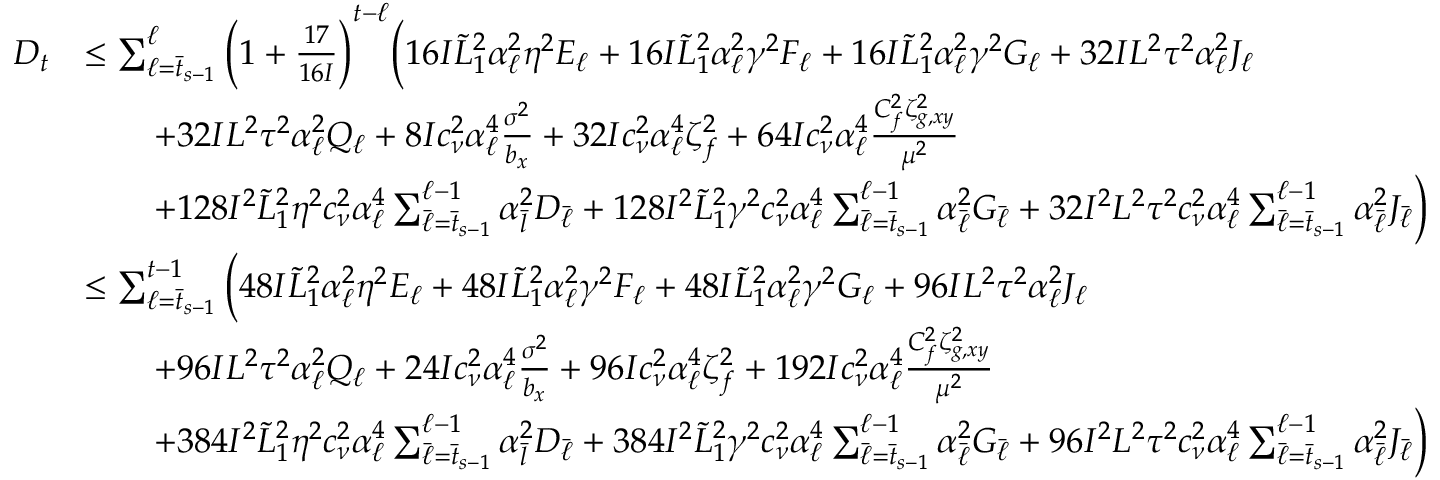<formula> <loc_0><loc_0><loc_500><loc_500>\begin{array} { r l } { D _ { t } } & { \leq \sum _ { \ell = \bar { t } _ { s - 1 } } ^ { \ell } \left ( 1 + \frac { 1 7 } { 1 6 I } \right ) ^ { t - \ell } \left ( 1 6 I \tilde { L } _ { 1 } ^ { 2 } \alpha _ { \ell } ^ { 2 } \eta ^ { 2 } E _ { \ell } + 1 6 I \tilde { L } _ { 1 } ^ { 2 } \alpha _ { \ell } ^ { 2 } \gamma ^ { 2 } F _ { \ell } + 1 6 I \tilde { L } _ { 1 } ^ { 2 } \alpha _ { \ell } ^ { 2 } \gamma ^ { 2 } G _ { \ell } + 3 2 I L ^ { 2 } \tau ^ { 2 } \alpha _ { \ell } ^ { 2 } J _ { \ell } } \\ & { \quad + 3 2 I L ^ { 2 } \tau ^ { 2 } \alpha _ { \ell } ^ { 2 } Q _ { \ell } + 8 I c _ { \nu } ^ { 2 } \alpha _ { \ell } ^ { 4 } \frac { \sigma ^ { 2 } } { b _ { x } } + 3 2 I c _ { \nu } ^ { 2 } \alpha _ { \ell } ^ { 4 } \zeta _ { f } ^ { 2 } + 6 4 I c _ { \nu } ^ { 2 } \alpha _ { \ell } ^ { 4 } \frac { C _ { f } ^ { 2 } \zeta _ { g , x y } ^ { 2 } } { \mu ^ { 2 } } } \\ & { \quad + 1 2 8 I ^ { 2 } \tilde { L } _ { 1 } ^ { 2 } \eta ^ { 2 } c _ { \nu } ^ { 2 } \alpha _ { \ell } ^ { 4 } \sum _ { \bar { \ell } = \bar { t } _ { s - 1 } } ^ { \ell - 1 } \alpha _ { \bar { l } } ^ { 2 } D _ { \bar { \ell } } + 1 2 8 I ^ { 2 } \tilde { L } _ { 1 } ^ { 2 } \gamma ^ { 2 } c _ { \nu } ^ { 2 } \alpha _ { \ell } ^ { 4 } \sum _ { \bar { \ell } = \bar { t } _ { s - 1 } } ^ { \ell - 1 } \alpha _ { \bar { \ell } } ^ { 2 } G _ { \bar { \ell } } + 3 2 I ^ { 2 } L ^ { 2 } \tau ^ { 2 } c _ { \nu } ^ { 2 } \alpha _ { \ell } ^ { 4 } \sum _ { \bar { \ell } = \bar { t } _ { s - 1 } } ^ { \ell - 1 } \alpha _ { \bar { \ell } } ^ { 2 } J _ { \bar { \ell } } \right ) } \\ & { \leq \sum _ { \ell = \bar { t } _ { s - 1 } } ^ { t - 1 } \left ( 4 8 I \tilde { L } _ { 1 } ^ { 2 } \alpha _ { \ell } ^ { 2 } \eta ^ { 2 } E _ { \ell } + 4 8 I \tilde { L } _ { 1 } ^ { 2 } \alpha _ { \ell } ^ { 2 } \gamma ^ { 2 } F _ { \ell } + 4 8 I \tilde { L } _ { 1 } ^ { 2 } \alpha _ { \ell } ^ { 2 } \gamma ^ { 2 } G _ { \ell } + 9 6 I L ^ { 2 } \tau ^ { 2 } \alpha _ { \ell } ^ { 2 } J _ { \ell } } \\ & { \quad + 9 6 I L ^ { 2 } \tau ^ { 2 } \alpha _ { \ell } ^ { 2 } Q _ { \ell } + 2 4 I c _ { \nu } ^ { 2 } \alpha _ { \ell } ^ { 4 } \frac { \sigma ^ { 2 } } { b _ { x } } + 9 6 I c _ { \nu } ^ { 2 } \alpha _ { \ell } ^ { 4 } \zeta _ { f } ^ { 2 } + 1 9 2 I c _ { \nu } ^ { 2 } \alpha _ { \ell } ^ { 4 } \frac { C _ { f } ^ { 2 } \zeta _ { g , x y } ^ { 2 } } { \mu ^ { 2 } } } \\ & { \quad + 3 8 4 I ^ { 2 } \tilde { L } _ { 1 } ^ { 2 } \eta ^ { 2 } c _ { \nu } ^ { 2 } \alpha _ { \ell } ^ { 4 } \sum _ { \bar { \ell } = \bar { t } _ { s - 1 } } ^ { \ell - 1 } \alpha _ { \bar { l } } ^ { 2 } D _ { \bar { \ell } } + 3 8 4 I ^ { 2 } \tilde { L } _ { 1 } ^ { 2 } \gamma ^ { 2 } c _ { \nu } ^ { 2 } \alpha _ { \ell } ^ { 4 } \sum _ { \bar { \ell } = \bar { t } _ { s - 1 } } ^ { \ell - 1 } \alpha _ { \bar { \ell } } ^ { 2 } G _ { \bar { \ell } } + 9 6 I ^ { 2 } L ^ { 2 } \tau ^ { 2 } c _ { \nu } ^ { 2 } \alpha _ { \ell } ^ { 4 } \sum _ { \bar { \ell } = \bar { t } _ { s - 1 } } ^ { \ell - 1 } \alpha _ { \bar { \ell } } ^ { 2 } J _ { \bar { \ell } } \right ) } \end{array}</formula> 